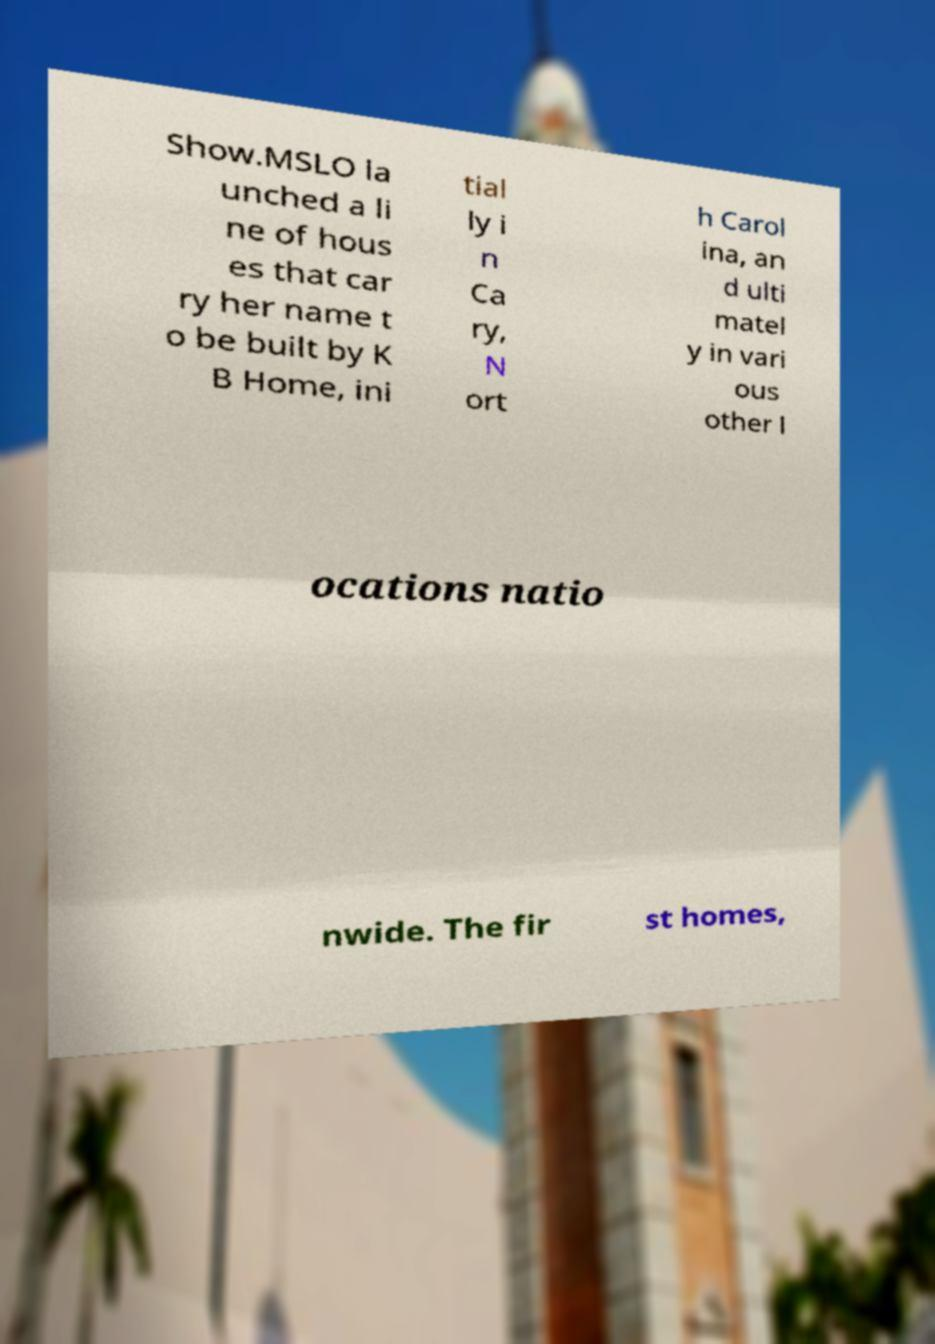Can you read and provide the text displayed in the image?This photo seems to have some interesting text. Can you extract and type it out for me? Show.MSLO la unched a li ne of hous es that car ry her name t o be built by K B Home, ini tial ly i n Ca ry, N ort h Carol ina, an d ulti matel y in vari ous other l ocations natio nwide. The fir st homes, 